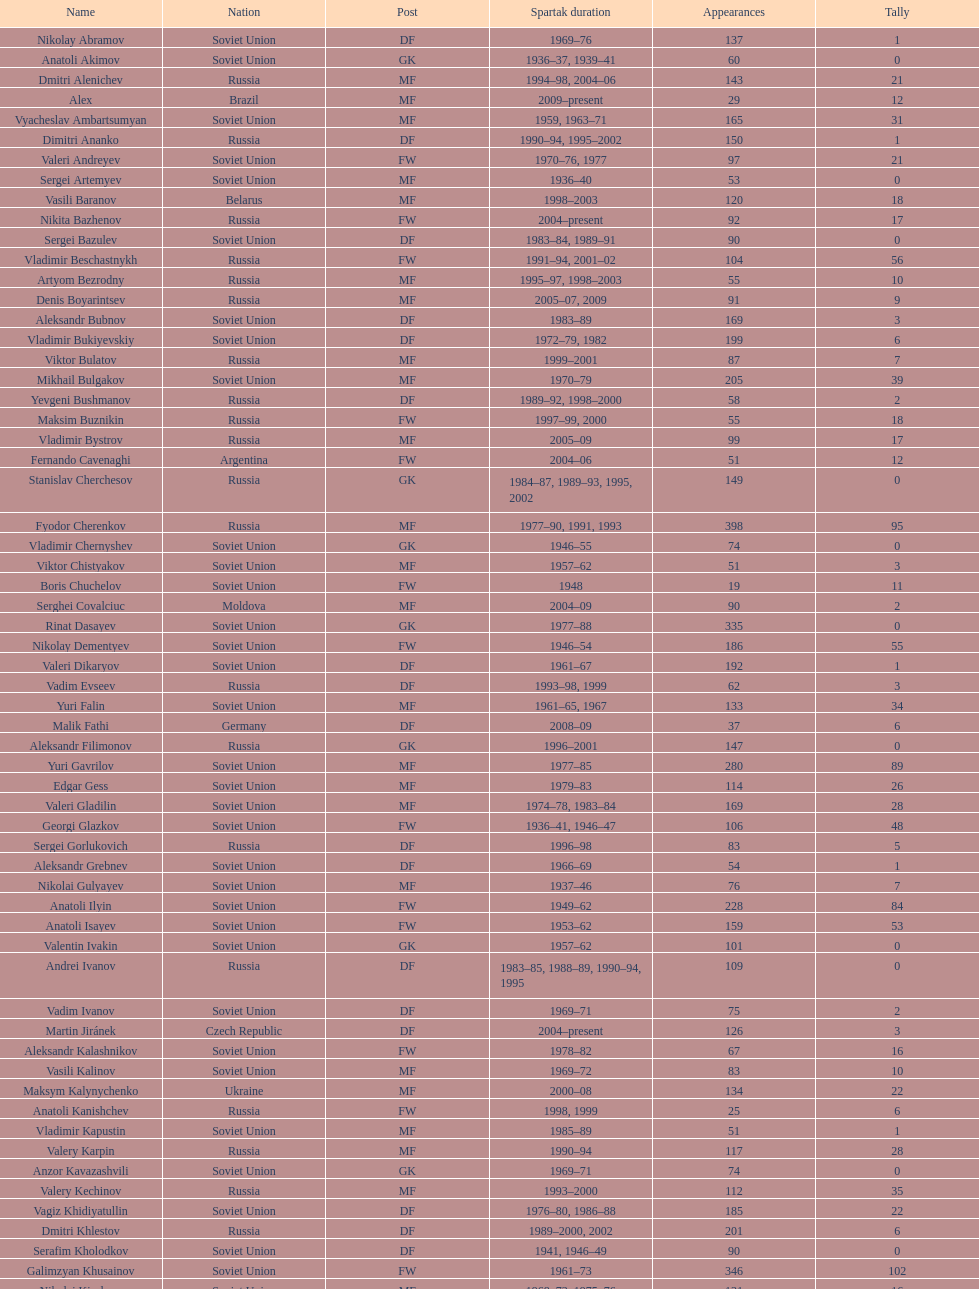Baranov has played from 2004 to the present. what is his nationality? Belarus. 